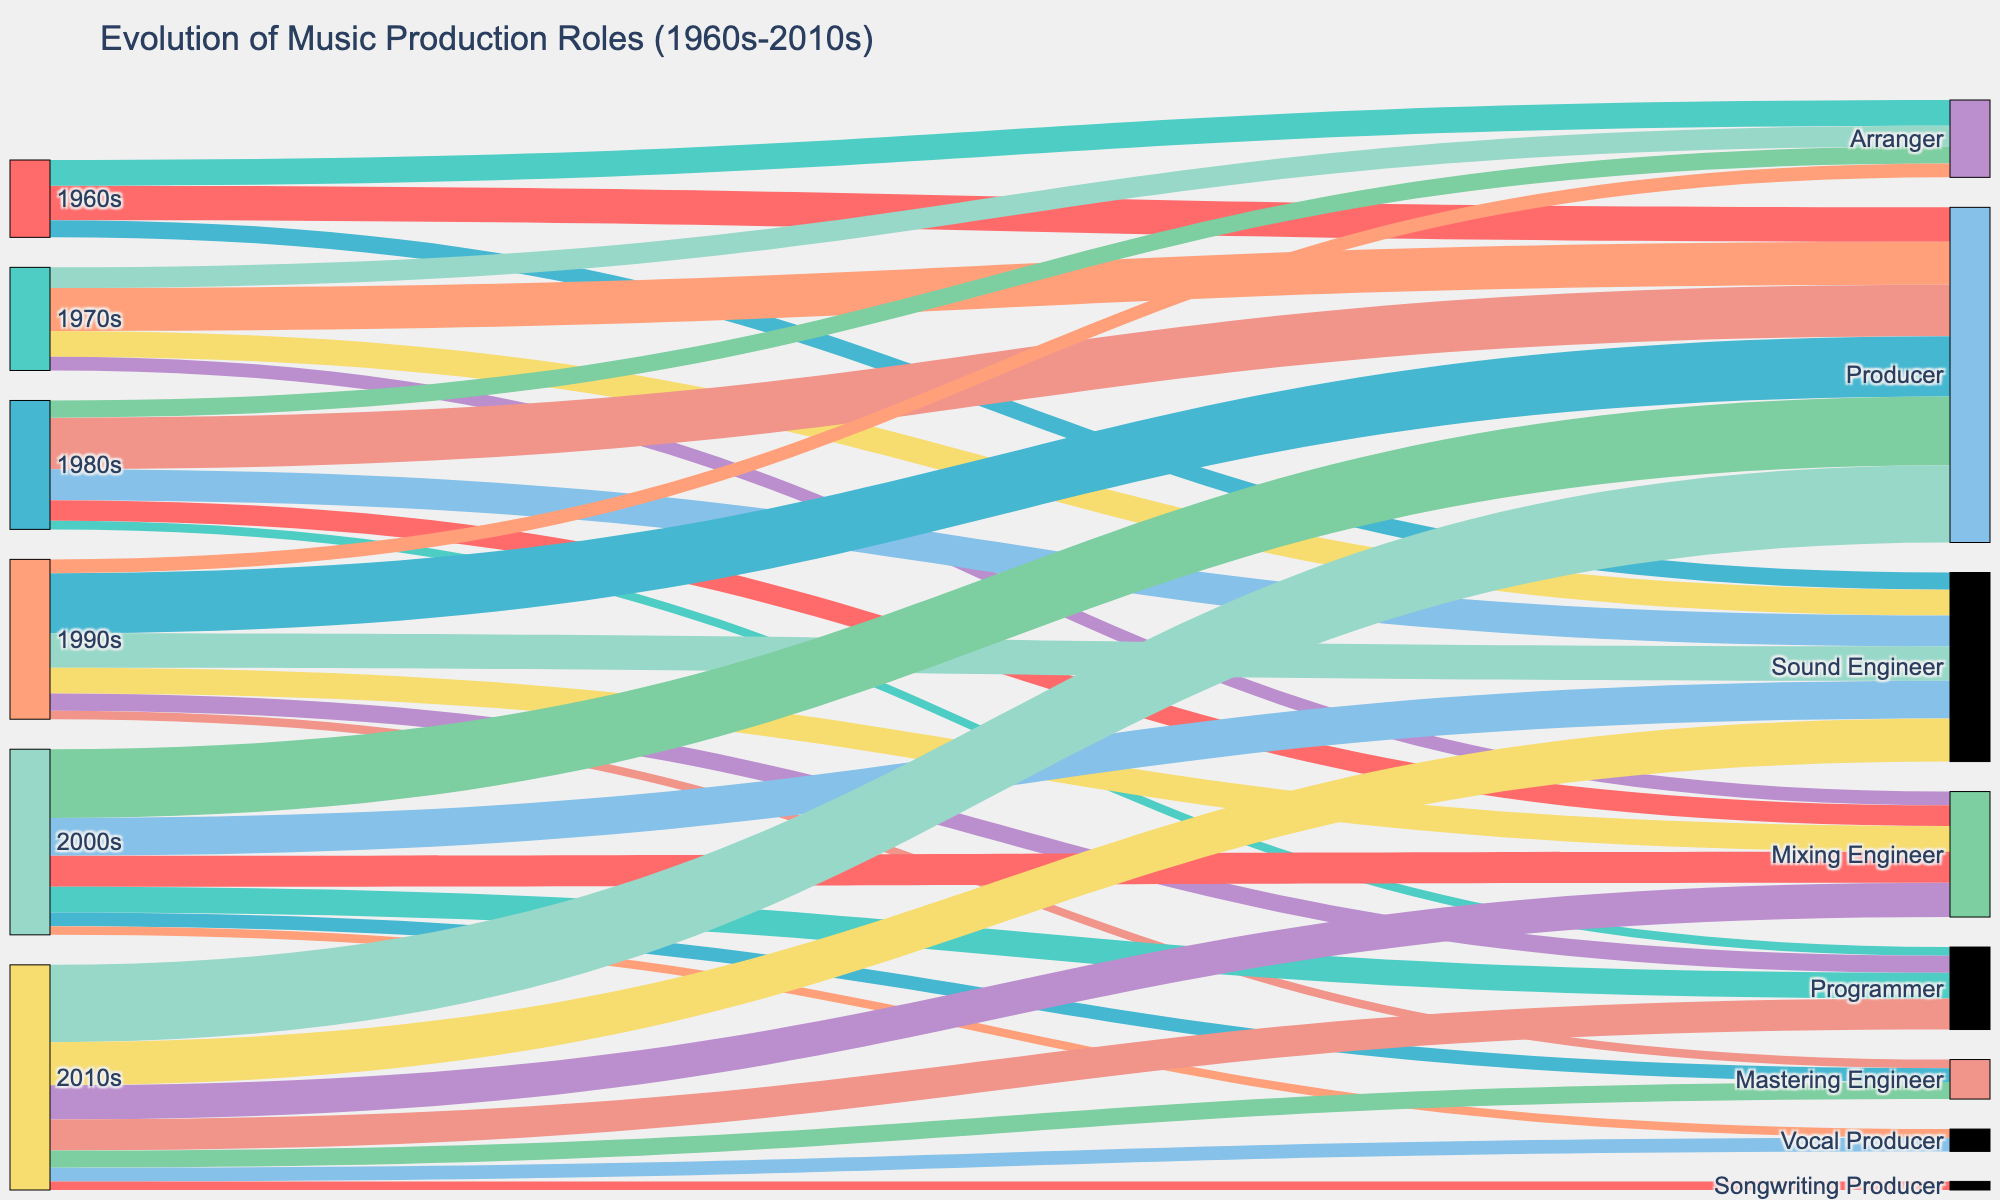How many production roles are listed for the 2010s? First, identify the production roles connected to the 2010s. They are Producer, Sound Engineer, Mixing Engineer, Programmer, Mastering Engineer, Vocal Producer, and Songwriting Producer. Counting these gives the total number of roles.
Answer: 7 What is the most frequently recognized role in the 1970s? Look at the connections from the 1970s and identify the most connected role. Producer has the highest value (25) in the 1970s.
Answer: Producer Which decade saw the introduction of the Programmer role? Identify the first appearance of the Programmer role by tracing back through the decades. The role first appears in the 1980s.
Answer: 1980s Compare the recognition of Sound Engineers in the 1960s and 2000s. Which decade had more credits? Look at the number of credits for Sound Engineers in both decades. The 1960s have 10, while the 2000s have 22. The 2000s have more credits.
Answer: 2000s Which role was newly recognized in the 2010s not present in previous decades? Identify roles in the 2010s and compare with previous decades. Songwriting Producer appears only in the 2010s.
Answer: Songwriting Producer What is the total number of credits for Producers from the 1960s to the 2010s? Sum the values for Producer for each decade: 20 (1960s) + 25 (1970s) + 30 (1980s) + 35 (1990s) + 40 (2000s) + 45 (2010s) = 195.
Answer: 195 How has the recognition of Mixing Engineers evolved from the 1970s to the 2010s? Track the values connected to Mixing Engineers across the decades: 8 (1970s), 12 (1980s), 15 (1990s), 18 (2000s), 20 (2010s). There is a general upward trend.
Answer: Increasing trend Is the recognition of Mastering Engineers greater or less than that of Vocal Producers in the 2010s? Find the values for both roles in the 2010s: Mastering Engineer (10), Vocal Producer (8). Mastering Engineers have a higher recognition.
Answer: Greater What decade had the lowest recognition for Arrangers? Compare the values for Arrangers across the decades: 15 (1960s), 12 (1970s), 10 (1980s), 8 (1990s). The 1990s is the lowest.
Answer: 1990s Which decade exhibited the most significant increase in the recognition of Producers compared to the previous decade? Calculate the increase in values for Producer between each consecutive decade and find the most significant. Increases are: 5 (1960s-1970s), 5 (1970s-1980s), 5 (1980s-1990s), 5 (1990s-2000s), 5 (2000s-2010s). All increases are equal.
Answer: No significant difference 